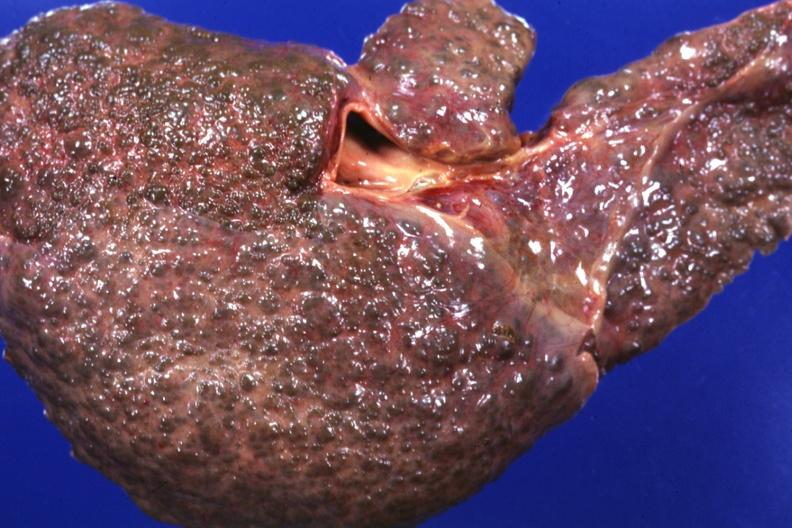s hepatobiliary present?
Answer the question using a single word or phrase. Yes 